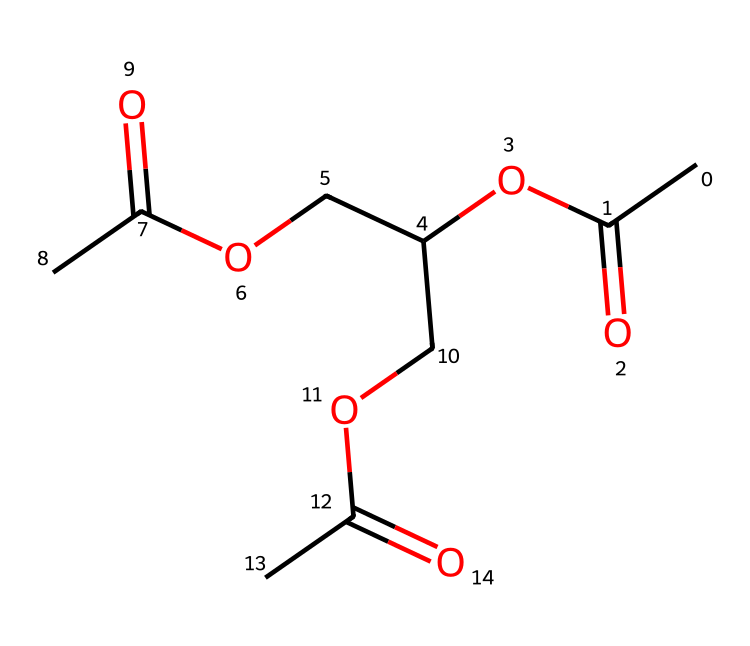What is the molecular formula of this compound? To determine the molecular formula, we need to count the number of each type of atom present in the SMILES representation. From CC(=O)OC(COC(C)=O)COC(C)=O, we identify 8 carbon (C) atoms, 12 hydrogen (H) atoms, and 6 oxygen (O) atoms, leading to the formula C8H12O6.
Answer: C8H12O6 How many ester functional groups are present in this chemical? The presence of ester functional groups can be deduced through the ester moieties represented by the -COO- segments in the structure. Upon analyzing the SMILES, we identify three distinct -COO- segments, indicating there are three ester functional groups.
Answer: three What type of chemical is represented by this structure? This chemical is classified as a polymer or a cellulose derivative due to its structure containing repeating acetic acid units linked via ester bonds. It is specifically an acetate polymer often used in fiber production.
Answer: polymer How many oxygen atoms are bonded to carbon in the structure? In the provided SMILES, we analyze the connectivity of oxygen atoms to carbon atoms. Each ester bond has an oxygen atom bonded to carbon, totaling six such bonds from the analysis of the entire structure, hence six oxygen atoms connected to carbon.
Answer: six What role does this compound play in early movie film stock? This compound, as an acetate, was primarily used as a film base material. Its chemical properties allowed for strong yet flexible film strips, leading to its widespread adoption for a variety of film types during early cinema production.
Answer: film base material 